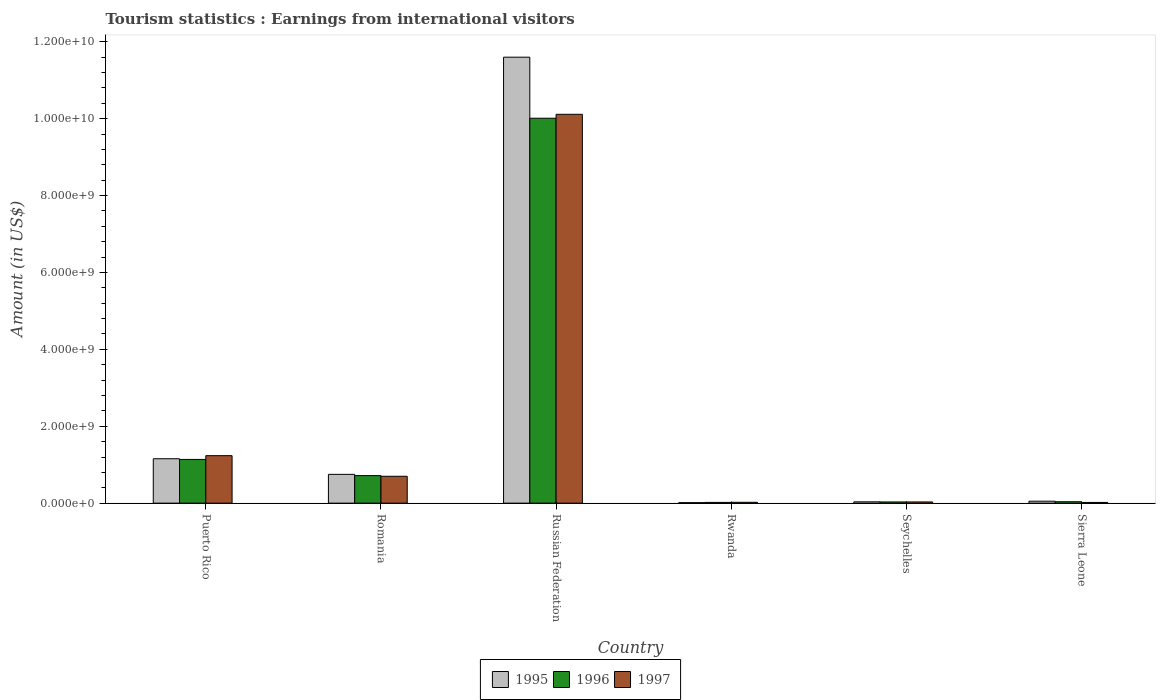How many groups of bars are there?
Offer a very short reply. 6. Are the number of bars per tick equal to the number of legend labels?
Make the answer very short. Yes. Are the number of bars on each tick of the X-axis equal?
Make the answer very short. Yes. What is the label of the 5th group of bars from the left?
Provide a succinct answer. Seychelles. In how many cases, is the number of bars for a given country not equal to the number of legend labels?
Provide a succinct answer. 0. What is the earnings from international visitors in 1997 in Rwanda?
Your response must be concise. 2.20e+07. Across all countries, what is the maximum earnings from international visitors in 1997?
Your answer should be very brief. 1.01e+1. Across all countries, what is the minimum earnings from international visitors in 1995?
Give a very brief answer. 1.30e+07. In which country was the earnings from international visitors in 1995 maximum?
Give a very brief answer. Russian Federation. In which country was the earnings from international visitors in 1996 minimum?
Offer a terse response. Rwanda. What is the total earnings from international visitors in 1995 in the graph?
Your answer should be very brief. 1.36e+1. What is the difference between the earnings from international visitors in 1997 in Russian Federation and that in Sierra Leone?
Your answer should be compact. 1.01e+1. What is the difference between the earnings from international visitors in 1996 in Seychelles and the earnings from international visitors in 1997 in Sierra Leone?
Make the answer very short. 1.29e+07. What is the average earnings from international visitors in 1996 per country?
Provide a short and direct response. 1.99e+09. What is the difference between the earnings from international visitors of/in 1995 and earnings from international visitors of/in 1996 in Romania?
Provide a succinct answer. 3.30e+07. What is the ratio of the earnings from international visitors in 1997 in Puerto Rico to that in Seychelles?
Your answer should be compact. 39.84. Is the difference between the earnings from international visitors in 1995 in Puerto Rico and Seychelles greater than the difference between the earnings from international visitors in 1996 in Puerto Rico and Seychelles?
Offer a very short reply. Yes. What is the difference between the highest and the second highest earnings from international visitors in 1996?
Offer a terse response. 9.30e+09. What is the difference between the highest and the lowest earnings from international visitors in 1995?
Your answer should be very brief. 1.16e+1. Is the sum of the earnings from international visitors in 1995 in Rwanda and Sierra Leone greater than the maximum earnings from international visitors in 1996 across all countries?
Provide a short and direct response. No. What does the 2nd bar from the right in Sierra Leone represents?
Your answer should be very brief. 1996. Is it the case that in every country, the sum of the earnings from international visitors in 1996 and earnings from international visitors in 1997 is greater than the earnings from international visitors in 1995?
Your answer should be very brief. Yes. How many bars are there?
Offer a very short reply. 18. Are the values on the major ticks of Y-axis written in scientific E-notation?
Offer a very short reply. Yes. Does the graph contain grids?
Your answer should be very brief. No. How are the legend labels stacked?
Offer a very short reply. Horizontal. What is the title of the graph?
Provide a short and direct response. Tourism statistics : Earnings from international visitors. Does "1967" appear as one of the legend labels in the graph?
Keep it short and to the point. No. What is the label or title of the X-axis?
Your response must be concise. Country. What is the Amount (in US$) of 1995 in Puerto Rico?
Offer a terse response. 1.16e+09. What is the Amount (in US$) in 1996 in Puerto Rico?
Your answer should be very brief. 1.14e+09. What is the Amount (in US$) in 1997 in Puerto Rico?
Your answer should be compact. 1.24e+09. What is the Amount (in US$) in 1995 in Romania?
Ensure brevity in your answer.  7.49e+08. What is the Amount (in US$) of 1996 in Romania?
Your response must be concise. 7.16e+08. What is the Amount (in US$) of 1997 in Romania?
Your response must be concise. 6.99e+08. What is the Amount (in US$) in 1995 in Russian Federation?
Your answer should be compact. 1.16e+1. What is the Amount (in US$) of 1996 in Russian Federation?
Offer a very short reply. 1.00e+1. What is the Amount (in US$) of 1997 in Russian Federation?
Your answer should be very brief. 1.01e+1. What is the Amount (in US$) of 1995 in Rwanda?
Your answer should be compact. 1.30e+07. What is the Amount (in US$) in 1996 in Rwanda?
Offer a terse response. 1.90e+07. What is the Amount (in US$) in 1997 in Rwanda?
Make the answer very short. 2.20e+07. What is the Amount (in US$) in 1995 in Seychelles?
Offer a terse response. 3.40e+07. What is the Amount (in US$) of 1996 in Seychelles?
Offer a terse response. 3.10e+07. What is the Amount (in US$) in 1997 in Seychelles?
Keep it short and to the point. 3.10e+07. What is the Amount (in US$) in 1995 in Sierra Leone?
Your answer should be very brief. 5.05e+07. What is the Amount (in US$) of 1996 in Sierra Leone?
Your response must be concise. 3.65e+07. What is the Amount (in US$) in 1997 in Sierra Leone?
Your answer should be compact. 1.81e+07. Across all countries, what is the maximum Amount (in US$) in 1995?
Your answer should be very brief. 1.16e+1. Across all countries, what is the maximum Amount (in US$) in 1996?
Keep it short and to the point. 1.00e+1. Across all countries, what is the maximum Amount (in US$) in 1997?
Your answer should be compact. 1.01e+1. Across all countries, what is the minimum Amount (in US$) of 1995?
Provide a succinct answer. 1.30e+07. Across all countries, what is the minimum Amount (in US$) of 1996?
Offer a terse response. 1.90e+07. Across all countries, what is the minimum Amount (in US$) of 1997?
Provide a succinct answer. 1.81e+07. What is the total Amount (in US$) of 1995 in the graph?
Your answer should be compact. 1.36e+1. What is the total Amount (in US$) of 1996 in the graph?
Provide a short and direct response. 1.20e+1. What is the total Amount (in US$) of 1997 in the graph?
Your answer should be compact. 1.21e+1. What is the difference between the Amount (in US$) of 1995 in Puerto Rico and that in Romania?
Provide a short and direct response. 4.06e+08. What is the difference between the Amount (in US$) in 1996 in Puerto Rico and that in Romania?
Keep it short and to the point. 4.21e+08. What is the difference between the Amount (in US$) in 1997 in Puerto Rico and that in Romania?
Provide a short and direct response. 5.36e+08. What is the difference between the Amount (in US$) of 1995 in Puerto Rico and that in Russian Federation?
Your answer should be very brief. -1.04e+1. What is the difference between the Amount (in US$) of 1996 in Puerto Rico and that in Russian Federation?
Your answer should be very brief. -8.87e+09. What is the difference between the Amount (in US$) in 1997 in Puerto Rico and that in Russian Federation?
Keep it short and to the point. -8.88e+09. What is the difference between the Amount (in US$) in 1995 in Puerto Rico and that in Rwanda?
Make the answer very short. 1.14e+09. What is the difference between the Amount (in US$) of 1996 in Puerto Rico and that in Rwanda?
Give a very brief answer. 1.12e+09. What is the difference between the Amount (in US$) of 1997 in Puerto Rico and that in Rwanda?
Provide a succinct answer. 1.21e+09. What is the difference between the Amount (in US$) of 1995 in Puerto Rico and that in Seychelles?
Make the answer very short. 1.12e+09. What is the difference between the Amount (in US$) of 1996 in Puerto Rico and that in Seychelles?
Make the answer very short. 1.11e+09. What is the difference between the Amount (in US$) in 1997 in Puerto Rico and that in Seychelles?
Provide a short and direct response. 1.20e+09. What is the difference between the Amount (in US$) in 1995 in Puerto Rico and that in Sierra Leone?
Keep it short and to the point. 1.10e+09. What is the difference between the Amount (in US$) of 1996 in Puerto Rico and that in Sierra Leone?
Your answer should be compact. 1.10e+09. What is the difference between the Amount (in US$) of 1997 in Puerto Rico and that in Sierra Leone?
Provide a short and direct response. 1.22e+09. What is the difference between the Amount (in US$) of 1995 in Romania and that in Russian Federation?
Give a very brief answer. -1.08e+1. What is the difference between the Amount (in US$) in 1996 in Romania and that in Russian Federation?
Offer a very short reply. -9.30e+09. What is the difference between the Amount (in US$) of 1997 in Romania and that in Russian Federation?
Offer a very short reply. -9.41e+09. What is the difference between the Amount (in US$) of 1995 in Romania and that in Rwanda?
Ensure brevity in your answer.  7.36e+08. What is the difference between the Amount (in US$) in 1996 in Romania and that in Rwanda?
Provide a succinct answer. 6.97e+08. What is the difference between the Amount (in US$) of 1997 in Romania and that in Rwanda?
Ensure brevity in your answer.  6.77e+08. What is the difference between the Amount (in US$) in 1995 in Romania and that in Seychelles?
Make the answer very short. 7.15e+08. What is the difference between the Amount (in US$) of 1996 in Romania and that in Seychelles?
Give a very brief answer. 6.85e+08. What is the difference between the Amount (in US$) in 1997 in Romania and that in Seychelles?
Provide a short and direct response. 6.68e+08. What is the difference between the Amount (in US$) in 1995 in Romania and that in Sierra Leone?
Offer a terse response. 6.98e+08. What is the difference between the Amount (in US$) of 1996 in Romania and that in Sierra Leone?
Provide a short and direct response. 6.80e+08. What is the difference between the Amount (in US$) in 1997 in Romania and that in Sierra Leone?
Make the answer very short. 6.81e+08. What is the difference between the Amount (in US$) in 1995 in Russian Federation and that in Rwanda?
Make the answer very short. 1.16e+1. What is the difference between the Amount (in US$) of 1996 in Russian Federation and that in Rwanda?
Offer a very short reply. 9.99e+09. What is the difference between the Amount (in US$) of 1997 in Russian Federation and that in Rwanda?
Provide a short and direct response. 1.01e+1. What is the difference between the Amount (in US$) in 1995 in Russian Federation and that in Seychelles?
Provide a short and direct response. 1.16e+1. What is the difference between the Amount (in US$) of 1996 in Russian Federation and that in Seychelles?
Provide a short and direct response. 9.98e+09. What is the difference between the Amount (in US$) in 1997 in Russian Federation and that in Seychelles?
Ensure brevity in your answer.  1.01e+1. What is the difference between the Amount (in US$) of 1995 in Russian Federation and that in Sierra Leone?
Provide a succinct answer. 1.15e+1. What is the difference between the Amount (in US$) in 1996 in Russian Federation and that in Sierra Leone?
Offer a very short reply. 9.97e+09. What is the difference between the Amount (in US$) in 1997 in Russian Federation and that in Sierra Leone?
Provide a short and direct response. 1.01e+1. What is the difference between the Amount (in US$) of 1995 in Rwanda and that in Seychelles?
Your response must be concise. -2.10e+07. What is the difference between the Amount (in US$) of 1996 in Rwanda and that in Seychelles?
Your answer should be compact. -1.20e+07. What is the difference between the Amount (in US$) of 1997 in Rwanda and that in Seychelles?
Provide a succinct answer. -9.00e+06. What is the difference between the Amount (in US$) in 1995 in Rwanda and that in Sierra Leone?
Make the answer very short. -3.75e+07. What is the difference between the Amount (in US$) in 1996 in Rwanda and that in Sierra Leone?
Provide a succinct answer. -1.75e+07. What is the difference between the Amount (in US$) of 1997 in Rwanda and that in Sierra Leone?
Your response must be concise. 3.90e+06. What is the difference between the Amount (in US$) of 1995 in Seychelles and that in Sierra Leone?
Provide a succinct answer. -1.65e+07. What is the difference between the Amount (in US$) in 1996 in Seychelles and that in Sierra Leone?
Offer a very short reply. -5.50e+06. What is the difference between the Amount (in US$) of 1997 in Seychelles and that in Sierra Leone?
Provide a succinct answer. 1.29e+07. What is the difference between the Amount (in US$) of 1995 in Puerto Rico and the Amount (in US$) of 1996 in Romania?
Offer a very short reply. 4.39e+08. What is the difference between the Amount (in US$) in 1995 in Puerto Rico and the Amount (in US$) in 1997 in Romania?
Provide a short and direct response. 4.56e+08. What is the difference between the Amount (in US$) of 1996 in Puerto Rico and the Amount (in US$) of 1997 in Romania?
Ensure brevity in your answer.  4.38e+08. What is the difference between the Amount (in US$) of 1995 in Puerto Rico and the Amount (in US$) of 1996 in Russian Federation?
Give a very brief answer. -8.86e+09. What is the difference between the Amount (in US$) of 1995 in Puerto Rico and the Amount (in US$) of 1997 in Russian Federation?
Provide a short and direct response. -8.96e+09. What is the difference between the Amount (in US$) of 1996 in Puerto Rico and the Amount (in US$) of 1997 in Russian Federation?
Offer a terse response. -8.98e+09. What is the difference between the Amount (in US$) of 1995 in Puerto Rico and the Amount (in US$) of 1996 in Rwanda?
Provide a short and direct response. 1.14e+09. What is the difference between the Amount (in US$) in 1995 in Puerto Rico and the Amount (in US$) in 1997 in Rwanda?
Your answer should be compact. 1.13e+09. What is the difference between the Amount (in US$) in 1996 in Puerto Rico and the Amount (in US$) in 1997 in Rwanda?
Offer a very short reply. 1.12e+09. What is the difference between the Amount (in US$) of 1995 in Puerto Rico and the Amount (in US$) of 1996 in Seychelles?
Give a very brief answer. 1.12e+09. What is the difference between the Amount (in US$) of 1995 in Puerto Rico and the Amount (in US$) of 1997 in Seychelles?
Your response must be concise. 1.12e+09. What is the difference between the Amount (in US$) in 1996 in Puerto Rico and the Amount (in US$) in 1997 in Seychelles?
Provide a short and direct response. 1.11e+09. What is the difference between the Amount (in US$) in 1995 in Puerto Rico and the Amount (in US$) in 1996 in Sierra Leone?
Ensure brevity in your answer.  1.12e+09. What is the difference between the Amount (in US$) in 1995 in Puerto Rico and the Amount (in US$) in 1997 in Sierra Leone?
Your answer should be very brief. 1.14e+09. What is the difference between the Amount (in US$) of 1996 in Puerto Rico and the Amount (in US$) of 1997 in Sierra Leone?
Make the answer very short. 1.12e+09. What is the difference between the Amount (in US$) in 1995 in Romania and the Amount (in US$) in 1996 in Russian Federation?
Provide a succinct answer. -9.26e+09. What is the difference between the Amount (in US$) of 1995 in Romania and the Amount (in US$) of 1997 in Russian Federation?
Offer a very short reply. -9.36e+09. What is the difference between the Amount (in US$) in 1996 in Romania and the Amount (in US$) in 1997 in Russian Federation?
Make the answer very short. -9.40e+09. What is the difference between the Amount (in US$) of 1995 in Romania and the Amount (in US$) of 1996 in Rwanda?
Offer a terse response. 7.30e+08. What is the difference between the Amount (in US$) of 1995 in Romania and the Amount (in US$) of 1997 in Rwanda?
Offer a very short reply. 7.27e+08. What is the difference between the Amount (in US$) of 1996 in Romania and the Amount (in US$) of 1997 in Rwanda?
Make the answer very short. 6.94e+08. What is the difference between the Amount (in US$) of 1995 in Romania and the Amount (in US$) of 1996 in Seychelles?
Give a very brief answer. 7.18e+08. What is the difference between the Amount (in US$) of 1995 in Romania and the Amount (in US$) of 1997 in Seychelles?
Offer a terse response. 7.18e+08. What is the difference between the Amount (in US$) in 1996 in Romania and the Amount (in US$) in 1997 in Seychelles?
Make the answer very short. 6.85e+08. What is the difference between the Amount (in US$) in 1995 in Romania and the Amount (in US$) in 1996 in Sierra Leone?
Keep it short and to the point. 7.12e+08. What is the difference between the Amount (in US$) of 1995 in Romania and the Amount (in US$) of 1997 in Sierra Leone?
Provide a succinct answer. 7.31e+08. What is the difference between the Amount (in US$) in 1996 in Romania and the Amount (in US$) in 1997 in Sierra Leone?
Provide a succinct answer. 6.98e+08. What is the difference between the Amount (in US$) in 1995 in Russian Federation and the Amount (in US$) in 1996 in Rwanda?
Ensure brevity in your answer.  1.16e+1. What is the difference between the Amount (in US$) in 1995 in Russian Federation and the Amount (in US$) in 1997 in Rwanda?
Offer a terse response. 1.16e+1. What is the difference between the Amount (in US$) of 1996 in Russian Federation and the Amount (in US$) of 1997 in Rwanda?
Your answer should be compact. 9.99e+09. What is the difference between the Amount (in US$) in 1995 in Russian Federation and the Amount (in US$) in 1996 in Seychelles?
Keep it short and to the point. 1.16e+1. What is the difference between the Amount (in US$) in 1995 in Russian Federation and the Amount (in US$) in 1997 in Seychelles?
Ensure brevity in your answer.  1.16e+1. What is the difference between the Amount (in US$) of 1996 in Russian Federation and the Amount (in US$) of 1997 in Seychelles?
Make the answer very short. 9.98e+09. What is the difference between the Amount (in US$) in 1995 in Russian Federation and the Amount (in US$) in 1996 in Sierra Leone?
Your answer should be compact. 1.16e+1. What is the difference between the Amount (in US$) in 1995 in Russian Federation and the Amount (in US$) in 1997 in Sierra Leone?
Keep it short and to the point. 1.16e+1. What is the difference between the Amount (in US$) in 1996 in Russian Federation and the Amount (in US$) in 1997 in Sierra Leone?
Offer a terse response. 9.99e+09. What is the difference between the Amount (in US$) of 1995 in Rwanda and the Amount (in US$) of 1996 in Seychelles?
Provide a succinct answer. -1.80e+07. What is the difference between the Amount (in US$) in 1995 in Rwanda and the Amount (in US$) in 1997 in Seychelles?
Ensure brevity in your answer.  -1.80e+07. What is the difference between the Amount (in US$) in 1996 in Rwanda and the Amount (in US$) in 1997 in Seychelles?
Your answer should be very brief. -1.20e+07. What is the difference between the Amount (in US$) in 1995 in Rwanda and the Amount (in US$) in 1996 in Sierra Leone?
Give a very brief answer. -2.35e+07. What is the difference between the Amount (in US$) of 1995 in Rwanda and the Amount (in US$) of 1997 in Sierra Leone?
Keep it short and to the point. -5.10e+06. What is the difference between the Amount (in US$) in 1996 in Rwanda and the Amount (in US$) in 1997 in Sierra Leone?
Offer a very short reply. 9.00e+05. What is the difference between the Amount (in US$) of 1995 in Seychelles and the Amount (in US$) of 1996 in Sierra Leone?
Offer a terse response. -2.50e+06. What is the difference between the Amount (in US$) of 1995 in Seychelles and the Amount (in US$) of 1997 in Sierra Leone?
Make the answer very short. 1.59e+07. What is the difference between the Amount (in US$) in 1996 in Seychelles and the Amount (in US$) in 1997 in Sierra Leone?
Keep it short and to the point. 1.29e+07. What is the average Amount (in US$) of 1995 per country?
Ensure brevity in your answer.  2.27e+09. What is the average Amount (in US$) of 1996 per country?
Your response must be concise. 1.99e+09. What is the average Amount (in US$) in 1997 per country?
Your response must be concise. 2.02e+09. What is the difference between the Amount (in US$) of 1995 and Amount (in US$) of 1996 in Puerto Rico?
Ensure brevity in your answer.  1.80e+07. What is the difference between the Amount (in US$) of 1995 and Amount (in US$) of 1997 in Puerto Rico?
Offer a terse response. -8.00e+07. What is the difference between the Amount (in US$) of 1996 and Amount (in US$) of 1997 in Puerto Rico?
Offer a terse response. -9.80e+07. What is the difference between the Amount (in US$) of 1995 and Amount (in US$) of 1996 in Romania?
Provide a succinct answer. 3.30e+07. What is the difference between the Amount (in US$) in 1995 and Amount (in US$) in 1997 in Romania?
Make the answer very short. 5.00e+07. What is the difference between the Amount (in US$) of 1996 and Amount (in US$) of 1997 in Romania?
Your answer should be compact. 1.70e+07. What is the difference between the Amount (in US$) of 1995 and Amount (in US$) of 1996 in Russian Federation?
Your response must be concise. 1.59e+09. What is the difference between the Amount (in US$) of 1995 and Amount (in US$) of 1997 in Russian Federation?
Your response must be concise. 1.49e+09. What is the difference between the Amount (in US$) in 1996 and Amount (in US$) in 1997 in Russian Federation?
Offer a terse response. -1.02e+08. What is the difference between the Amount (in US$) in 1995 and Amount (in US$) in 1996 in Rwanda?
Make the answer very short. -6.00e+06. What is the difference between the Amount (in US$) in 1995 and Amount (in US$) in 1997 in Rwanda?
Provide a short and direct response. -9.00e+06. What is the difference between the Amount (in US$) in 1995 and Amount (in US$) in 1996 in Seychelles?
Make the answer very short. 3.00e+06. What is the difference between the Amount (in US$) of 1996 and Amount (in US$) of 1997 in Seychelles?
Provide a succinct answer. 0. What is the difference between the Amount (in US$) of 1995 and Amount (in US$) of 1996 in Sierra Leone?
Give a very brief answer. 1.40e+07. What is the difference between the Amount (in US$) of 1995 and Amount (in US$) of 1997 in Sierra Leone?
Your response must be concise. 3.24e+07. What is the difference between the Amount (in US$) of 1996 and Amount (in US$) of 1997 in Sierra Leone?
Give a very brief answer. 1.84e+07. What is the ratio of the Amount (in US$) of 1995 in Puerto Rico to that in Romania?
Make the answer very short. 1.54. What is the ratio of the Amount (in US$) in 1996 in Puerto Rico to that in Romania?
Give a very brief answer. 1.59. What is the ratio of the Amount (in US$) of 1997 in Puerto Rico to that in Romania?
Give a very brief answer. 1.77. What is the ratio of the Amount (in US$) in 1995 in Puerto Rico to that in Russian Federation?
Your response must be concise. 0.1. What is the ratio of the Amount (in US$) of 1996 in Puerto Rico to that in Russian Federation?
Provide a succinct answer. 0.11. What is the ratio of the Amount (in US$) of 1997 in Puerto Rico to that in Russian Federation?
Make the answer very short. 0.12. What is the ratio of the Amount (in US$) of 1995 in Puerto Rico to that in Rwanda?
Ensure brevity in your answer.  88.85. What is the ratio of the Amount (in US$) of 1996 in Puerto Rico to that in Rwanda?
Ensure brevity in your answer.  59.84. What is the ratio of the Amount (in US$) of 1997 in Puerto Rico to that in Rwanda?
Offer a terse response. 56.14. What is the ratio of the Amount (in US$) in 1995 in Puerto Rico to that in Seychelles?
Offer a terse response. 33.97. What is the ratio of the Amount (in US$) of 1996 in Puerto Rico to that in Seychelles?
Your answer should be compact. 36.68. What is the ratio of the Amount (in US$) in 1997 in Puerto Rico to that in Seychelles?
Offer a terse response. 39.84. What is the ratio of the Amount (in US$) of 1995 in Puerto Rico to that in Sierra Leone?
Provide a succinct answer. 22.87. What is the ratio of the Amount (in US$) of 1996 in Puerto Rico to that in Sierra Leone?
Your response must be concise. 31.15. What is the ratio of the Amount (in US$) in 1997 in Puerto Rico to that in Sierra Leone?
Give a very brief answer. 68.23. What is the ratio of the Amount (in US$) of 1995 in Romania to that in Russian Federation?
Give a very brief answer. 0.06. What is the ratio of the Amount (in US$) of 1996 in Romania to that in Russian Federation?
Make the answer very short. 0.07. What is the ratio of the Amount (in US$) in 1997 in Romania to that in Russian Federation?
Ensure brevity in your answer.  0.07. What is the ratio of the Amount (in US$) of 1995 in Romania to that in Rwanda?
Give a very brief answer. 57.62. What is the ratio of the Amount (in US$) of 1996 in Romania to that in Rwanda?
Provide a short and direct response. 37.68. What is the ratio of the Amount (in US$) in 1997 in Romania to that in Rwanda?
Give a very brief answer. 31.77. What is the ratio of the Amount (in US$) in 1995 in Romania to that in Seychelles?
Provide a short and direct response. 22.03. What is the ratio of the Amount (in US$) of 1996 in Romania to that in Seychelles?
Your answer should be very brief. 23.1. What is the ratio of the Amount (in US$) in 1997 in Romania to that in Seychelles?
Provide a short and direct response. 22.55. What is the ratio of the Amount (in US$) in 1995 in Romania to that in Sierra Leone?
Make the answer very short. 14.83. What is the ratio of the Amount (in US$) of 1996 in Romania to that in Sierra Leone?
Your answer should be compact. 19.62. What is the ratio of the Amount (in US$) in 1997 in Romania to that in Sierra Leone?
Give a very brief answer. 38.62. What is the ratio of the Amount (in US$) of 1995 in Russian Federation to that in Rwanda?
Keep it short and to the point. 892.23. What is the ratio of the Amount (in US$) in 1996 in Russian Federation to that in Rwanda?
Ensure brevity in your answer.  526.89. What is the ratio of the Amount (in US$) in 1997 in Russian Federation to that in Rwanda?
Offer a terse response. 459.68. What is the ratio of the Amount (in US$) in 1995 in Russian Federation to that in Seychelles?
Your answer should be compact. 341.15. What is the ratio of the Amount (in US$) of 1996 in Russian Federation to that in Seychelles?
Provide a succinct answer. 322.94. What is the ratio of the Amount (in US$) in 1997 in Russian Federation to that in Seychelles?
Make the answer very short. 326.23. What is the ratio of the Amount (in US$) in 1995 in Russian Federation to that in Sierra Leone?
Give a very brief answer. 229.68. What is the ratio of the Amount (in US$) of 1996 in Russian Federation to that in Sierra Leone?
Provide a short and direct response. 274.27. What is the ratio of the Amount (in US$) of 1997 in Russian Federation to that in Sierra Leone?
Provide a short and direct response. 558.73. What is the ratio of the Amount (in US$) of 1995 in Rwanda to that in Seychelles?
Keep it short and to the point. 0.38. What is the ratio of the Amount (in US$) of 1996 in Rwanda to that in Seychelles?
Provide a short and direct response. 0.61. What is the ratio of the Amount (in US$) of 1997 in Rwanda to that in Seychelles?
Offer a terse response. 0.71. What is the ratio of the Amount (in US$) in 1995 in Rwanda to that in Sierra Leone?
Your answer should be compact. 0.26. What is the ratio of the Amount (in US$) of 1996 in Rwanda to that in Sierra Leone?
Make the answer very short. 0.52. What is the ratio of the Amount (in US$) of 1997 in Rwanda to that in Sierra Leone?
Ensure brevity in your answer.  1.22. What is the ratio of the Amount (in US$) of 1995 in Seychelles to that in Sierra Leone?
Keep it short and to the point. 0.67. What is the ratio of the Amount (in US$) of 1996 in Seychelles to that in Sierra Leone?
Ensure brevity in your answer.  0.85. What is the ratio of the Amount (in US$) of 1997 in Seychelles to that in Sierra Leone?
Provide a succinct answer. 1.71. What is the difference between the highest and the second highest Amount (in US$) in 1995?
Ensure brevity in your answer.  1.04e+1. What is the difference between the highest and the second highest Amount (in US$) in 1996?
Provide a short and direct response. 8.87e+09. What is the difference between the highest and the second highest Amount (in US$) in 1997?
Your answer should be compact. 8.88e+09. What is the difference between the highest and the lowest Amount (in US$) in 1995?
Keep it short and to the point. 1.16e+1. What is the difference between the highest and the lowest Amount (in US$) of 1996?
Give a very brief answer. 9.99e+09. What is the difference between the highest and the lowest Amount (in US$) of 1997?
Provide a succinct answer. 1.01e+1. 